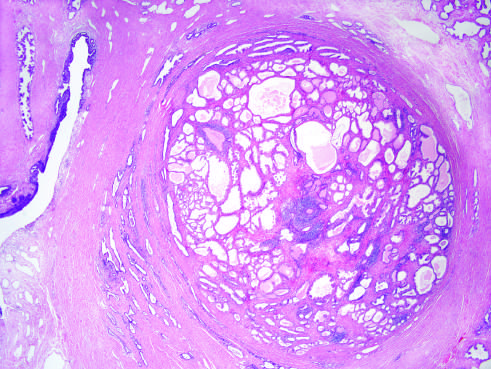does the blue area demonstrate a well-demarcated nodule at the right of the field, with a portion of urethra seen to the left?
Answer the question using a single word or phrase. No 